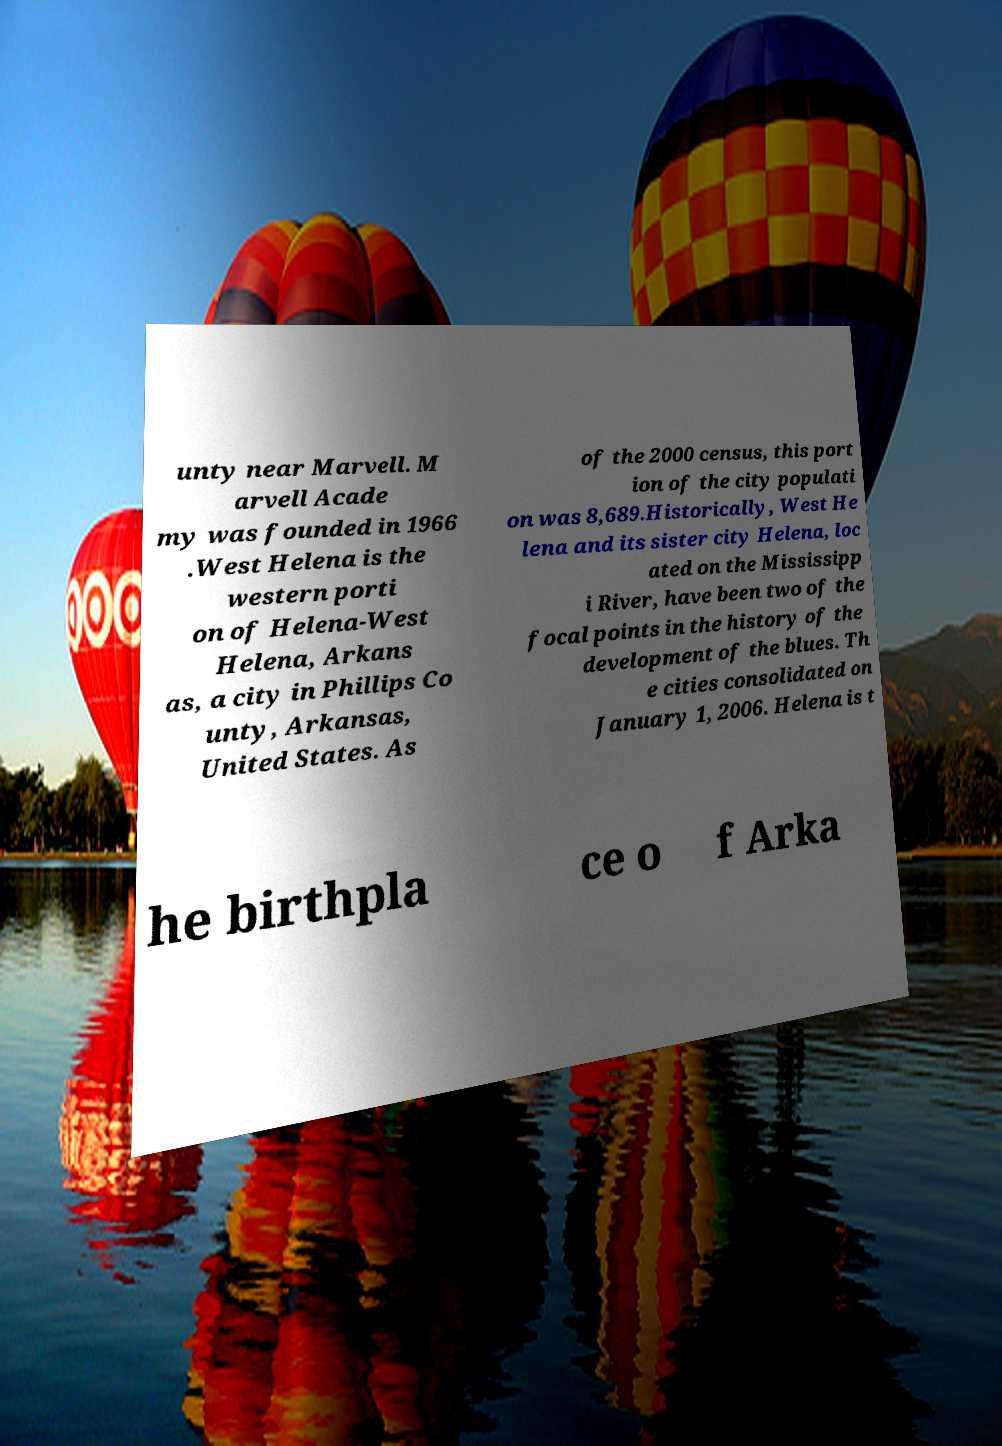I need the written content from this picture converted into text. Can you do that? unty near Marvell. M arvell Acade my was founded in 1966 .West Helena is the western porti on of Helena-West Helena, Arkans as, a city in Phillips Co unty, Arkansas, United States. As of the 2000 census, this port ion of the city populati on was 8,689.Historically, West He lena and its sister city Helena, loc ated on the Mississipp i River, have been two of the focal points in the history of the development of the blues. Th e cities consolidated on January 1, 2006. Helena is t he birthpla ce o f Arka 